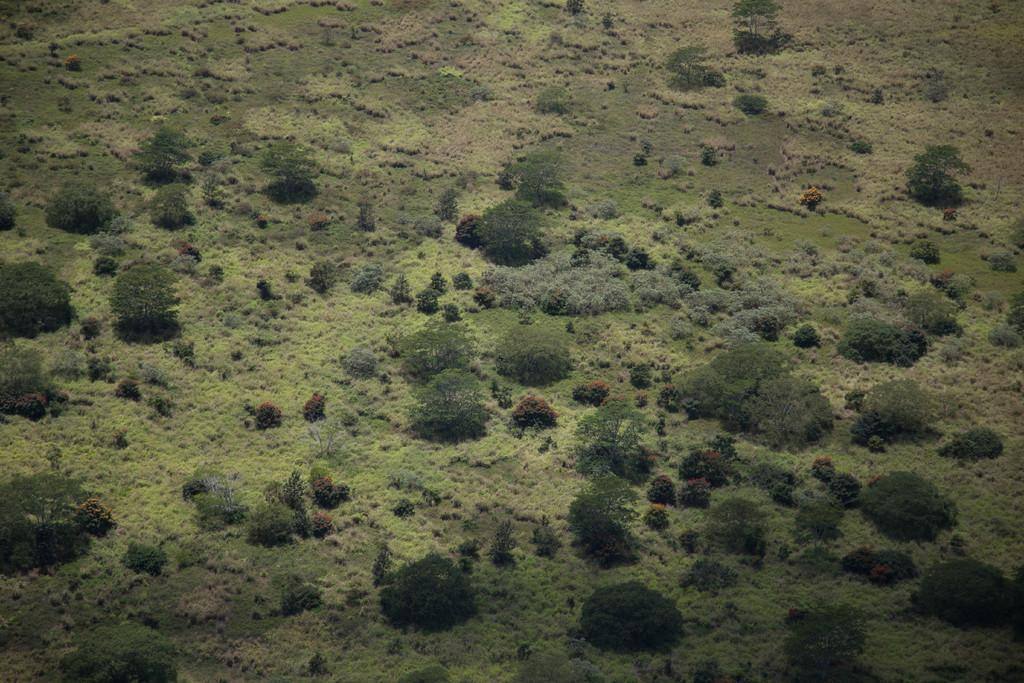Describe this image in one or two sentences. This picture shows trees and few plants. 